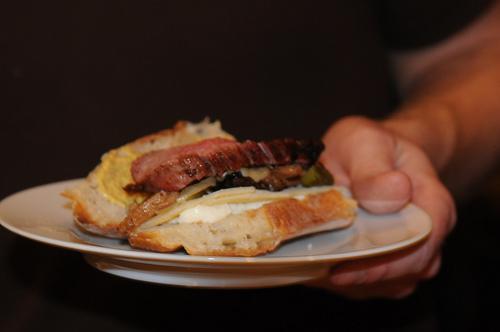How many sandwiches are on the plate?
Give a very brief answer. 1. How many hands are in the photo?
Give a very brief answer. 1. 